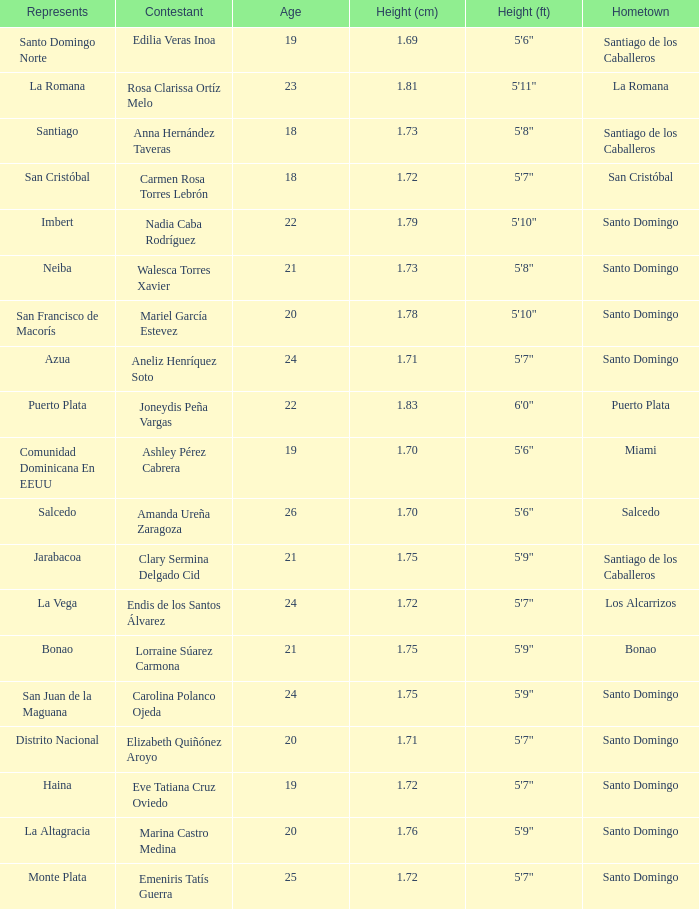Name the total number of represents for clary sermina delgado cid 1.0. 